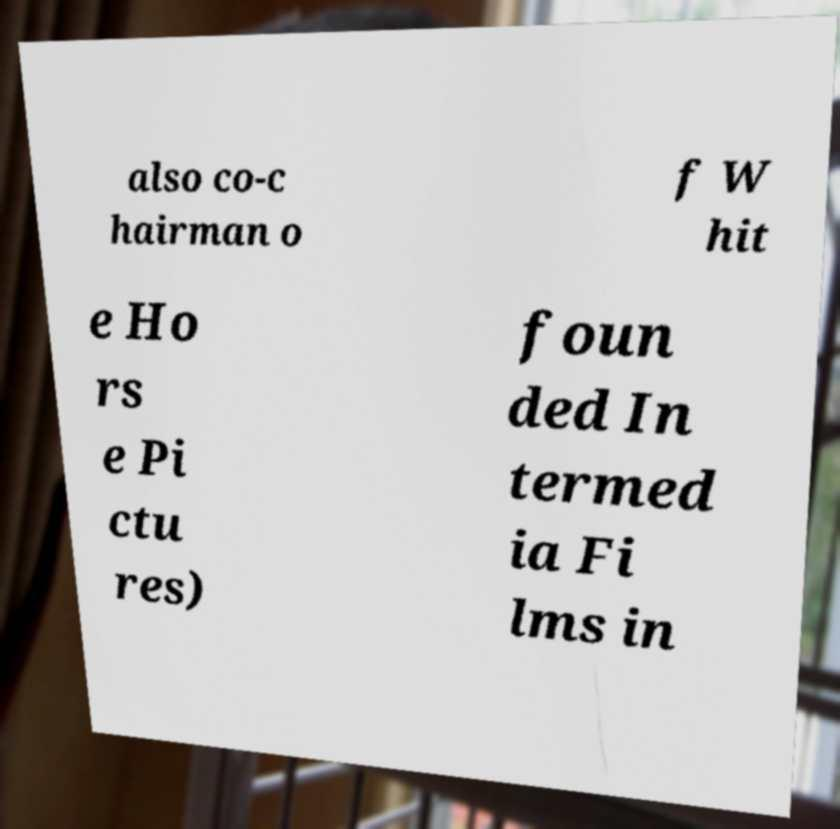What messages or text are displayed in this image? I need them in a readable, typed format. also co-c hairman o f W hit e Ho rs e Pi ctu res) foun ded In termed ia Fi lms in 